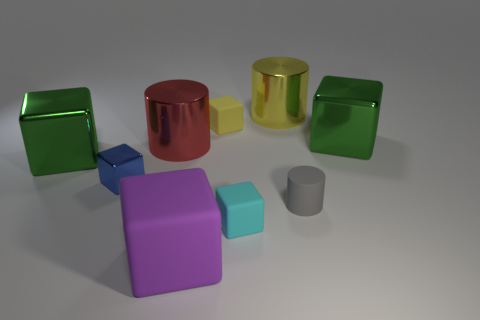How many other objects are there of the same color as the tiny cylinder?
Provide a succinct answer. 0. The small matte object that is both on the left side of the tiny gray object and in front of the large red metallic thing is what color?
Your response must be concise. Cyan. What number of red things are there?
Offer a terse response. 1. Does the large purple thing have the same material as the big red thing?
Offer a very short reply. No. The tiny blue thing right of the green object that is to the left of the rubber object right of the small cyan object is what shape?
Ensure brevity in your answer.  Cube. Is the material of the green object to the left of the big yellow shiny cylinder the same as the green block that is to the right of the blue metal block?
Offer a very short reply. Yes. What is the material of the tiny blue cube?
Your response must be concise. Metal. What number of other large objects have the same shape as the blue object?
Provide a succinct answer. 3. There is a small rubber cube that is behind the green object that is in front of the large red thing that is behind the matte cylinder; what is its color?
Make the answer very short. Yellow. What number of large things are either matte cubes or blue metallic cylinders?
Ensure brevity in your answer.  1. 